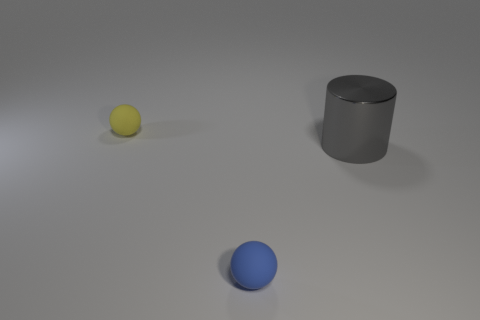Add 3 tiny brown metallic blocks. How many objects exist? 6 Subtract all cylinders. How many objects are left? 2 Subtract all gray balls. How many green cylinders are left? 0 Add 2 blue objects. How many blue objects are left? 3 Add 2 big red cubes. How many big red cubes exist? 2 Subtract 1 gray cylinders. How many objects are left? 2 Subtract all red cylinders. Subtract all purple blocks. How many cylinders are left? 1 Subtract all gray metallic things. Subtract all big things. How many objects are left? 1 